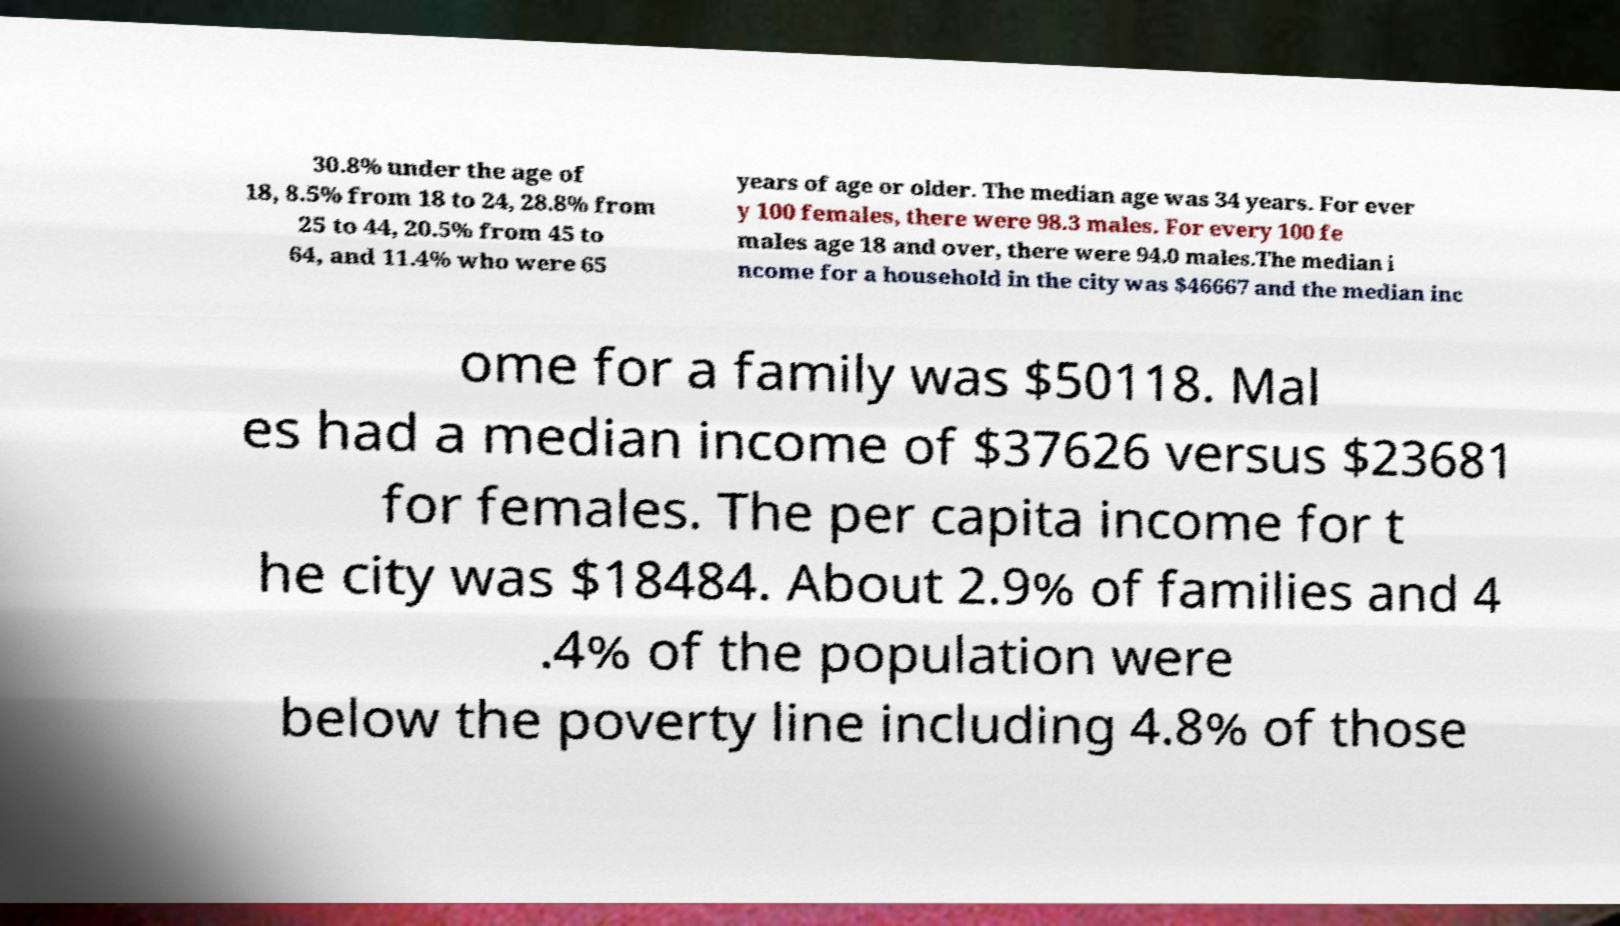Can you accurately transcribe the text from the provided image for me? 30.8% under the age of 18, 8.5% from 18 to 24, 28.8% from 25 to 44, 20.5% from 45 to 64, and 11.4% who were 65 years of age or older. The median age was 34 years. For ever y 100 females, there were 98.3 males. For every 100 fe males age 18 and over, there were 94.0 males.The median i ncome for a household in the city was $46667 and the median inc ome for a family was $50118. Mal es had a median income of $37626 versus $23681 for females. The per capita income for t he city was $18484. About 2.9% of families and 4 .4% of the population were below the poverty line including 4.8% of those 